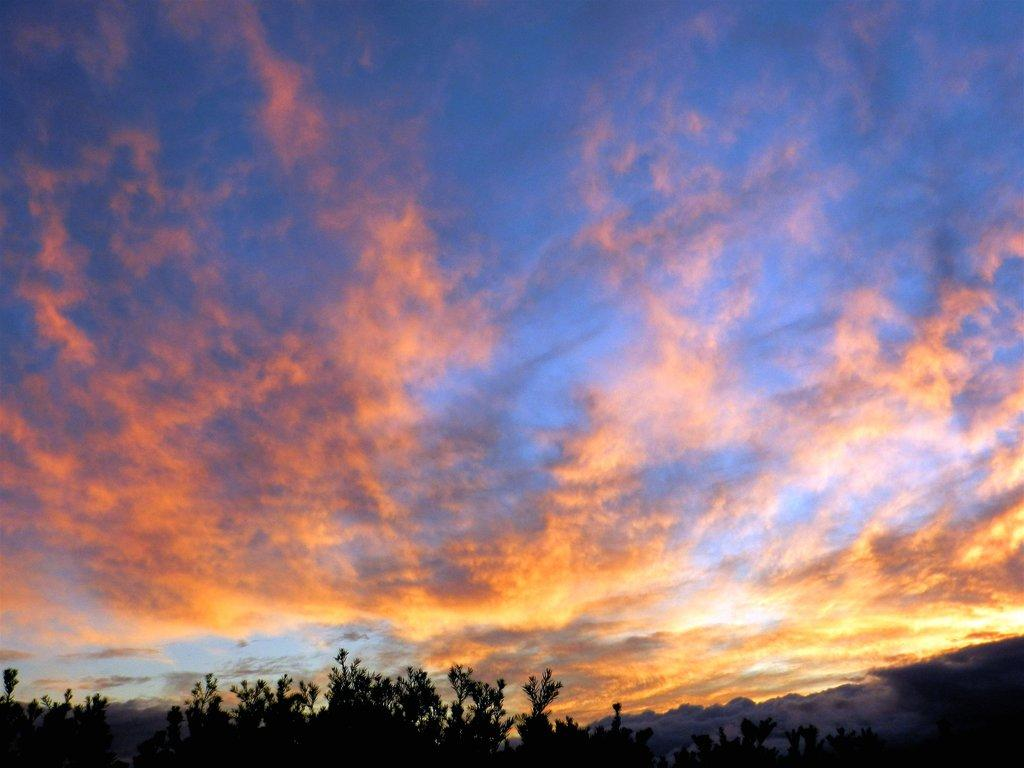What is the condition of the sky in the image? The sky is cloudy in the image. What type of vegetation can be seen in the image? There are trees visible in the image. Is there a visible connection between the trees in the image? There is no mention of a connection between the trees in the image, and it cannot be determined from the provided facts. Can you see any tooth in the image? There is no tooth present in the image. 